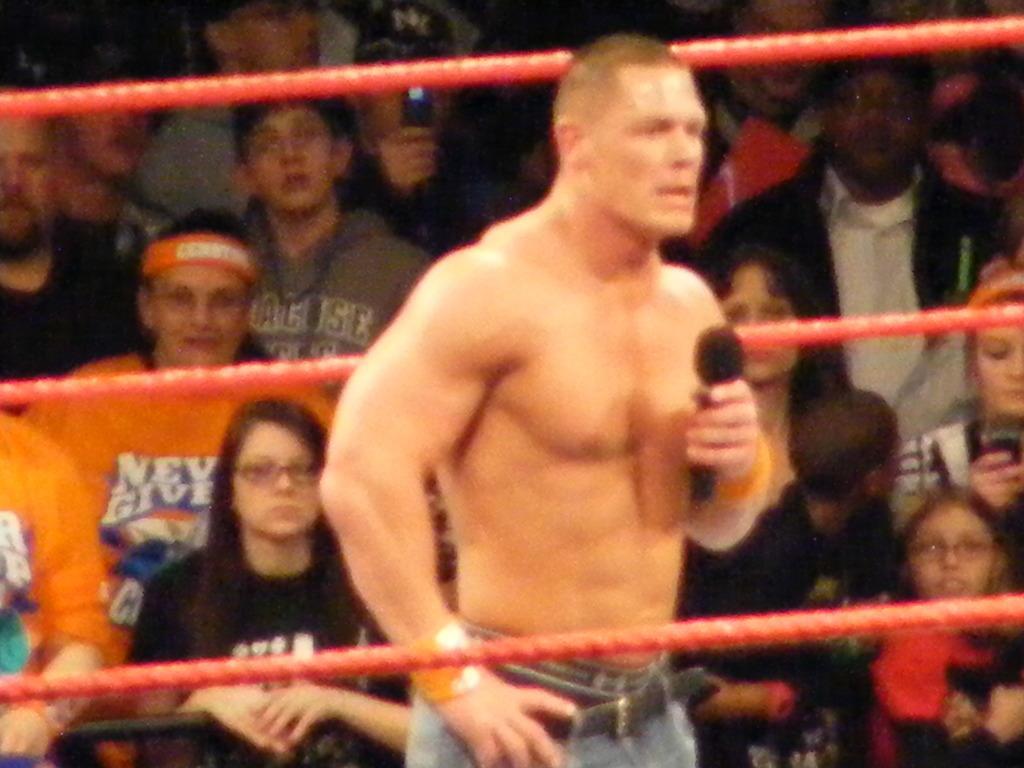Describe this image in one or two sentences. As we can see in the image there are group of people sitting and in the front there is a man holding mic. 